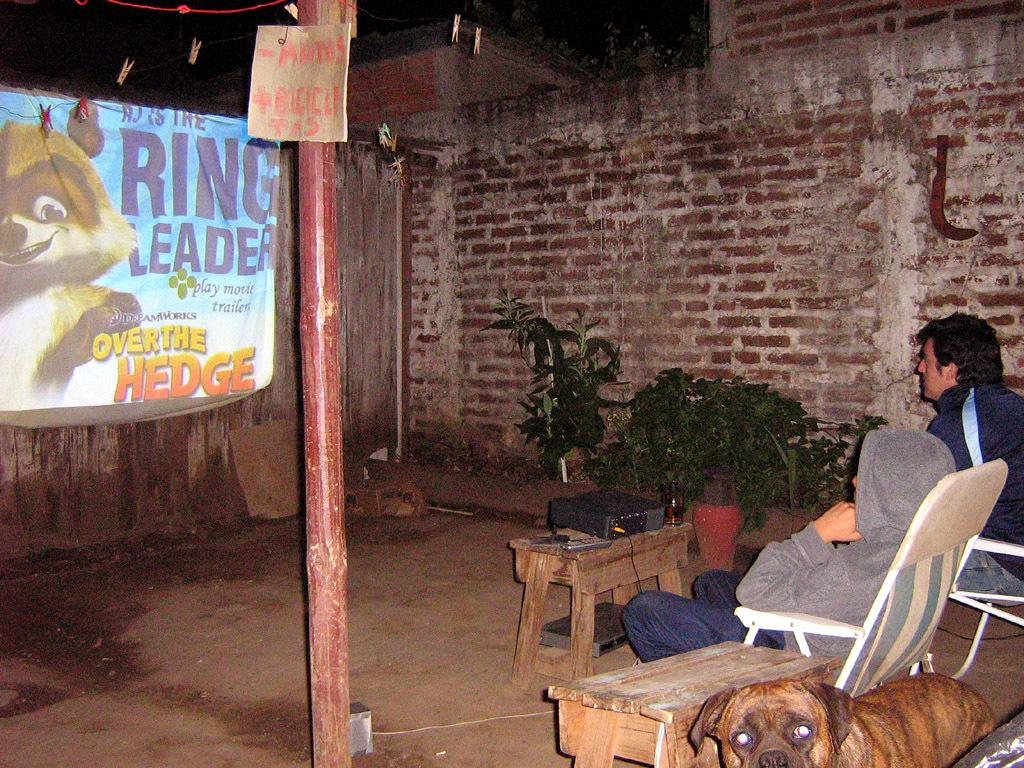How many persons are sitting in chairs in the image? There are two persons sitting in chairs in the image. What other living creature can be seen in the image? There is a dog in the image. What type of vegetation is present in the image? There are plants in the image. What type of furniture is visible in the image? There are tables in the image. What device is used for displaying visuals in the image? A projector is present in the image. What is used to display the projected image? There is a screen in the image. What type of structure is visible in the image? There is a wall in the image. What type of fasteners are visible in the image? Clips are visible in the image. What type of material is present in the image for tying or securing objects? Rope is present in the image. What type of tool is visible in the image? A knife is visible in the image. What type of nut is being cracked open with the knife in the image? There is no nut present in the image, nor is there any indication that a knife is being used to crack open a nut. What type of alarm is going off in the image? There is no alarm present in the image, nor is there any indication of an alarm going off. 